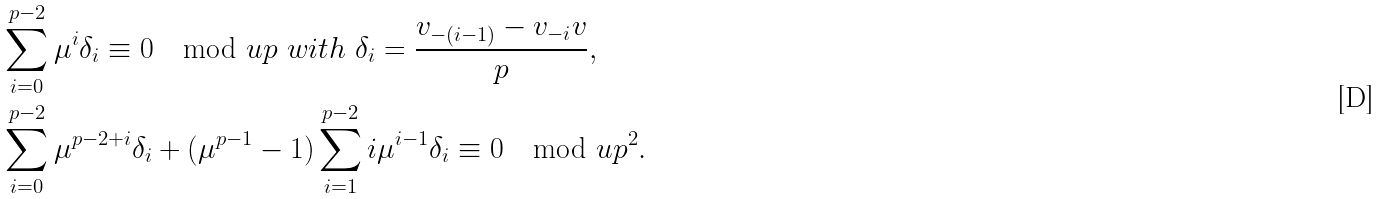<formula> <loc_0><loc_0><loc_500><loc_500>& \sum _ { i = 0 } ^ { p - 2 } \mu ^ { i } \delta _ { i } \equiv 0 \mod u p \ w i t h \ \delta _ { i } = \frac { v _ { - ( i - 1 ) } - v _ { - i } v } { p } , \\ & \sum _ { i = 0 } ^ { p - 2 } \mu ^ { p - 2 + i } \delta _ { i } + ( \mu ^ { p - 1 } - 1 ) \sum _ { i = 1 } ^ { p - 2 } i \mu ^ { i - 1 } \delta _ { i } \equiv 0 \mod u p ^ { 2 } . \\</formula> 